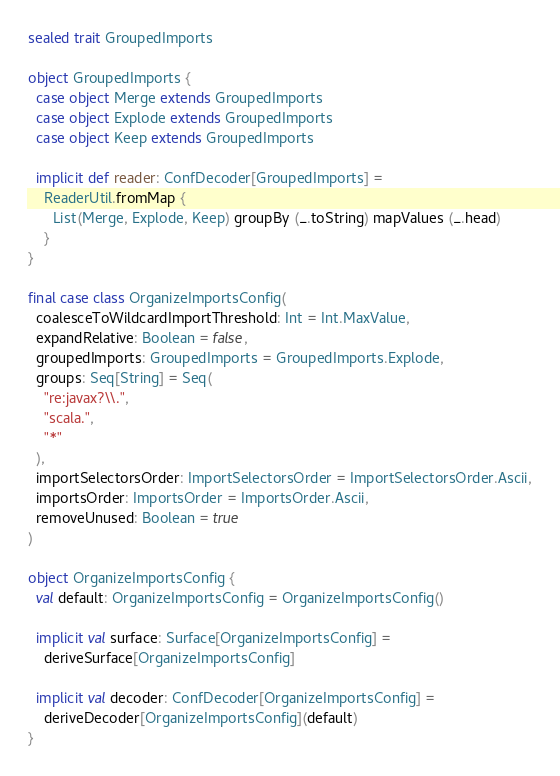<code> <loc_0><loc_0><loc_500><loc_500><_Scala_>sealed trait GroupedImports

object GroupedImports {
  case object Merge extends GroupedImports
  case object Explode extends GroupedImports
  case object Keep extends GroupedImports

  implicit def reader: ConfDecoder[GroupedImports] =
    ReaderUtil.fromMap {
      List(Merge, Explode, Keep) groupBy (_.toString) mapValues (_.head)
    }
}

final case class OrganizeImportsConfig(
  coalesceToWildcardImportThreshold: Int = Int.MaxValue,
  expandRelative: Boolean = false,
  groupedImports: GroupedImports = GroupedImports.Explode,
  groups: Seq[String] = Seq(
    "re:javax?\\.",
    "scala.",
    "*"
  ),
  importSelectorsOrder: ImportSelectorsOrder = ImportSelectorsOrder.Ascii,
  importsOrder: ImportsOrder = ImportsOrder.Ascii,
  removeUnused: Boolean = true
)

object OrganizeImportsConfig {
  val default: OrganizeImportsConfig = OrganizeImportsConfig()

  implicit val surface: Surface[OrganizeImportsConfig] =
    deriveSurface[OrganizeImportsConfig]

  implicit val decoder: ConfDecoder[OrganizeImportsConfig] =
    deriveDecoder[OrganizeImportsConfig](default)
}
</code> 